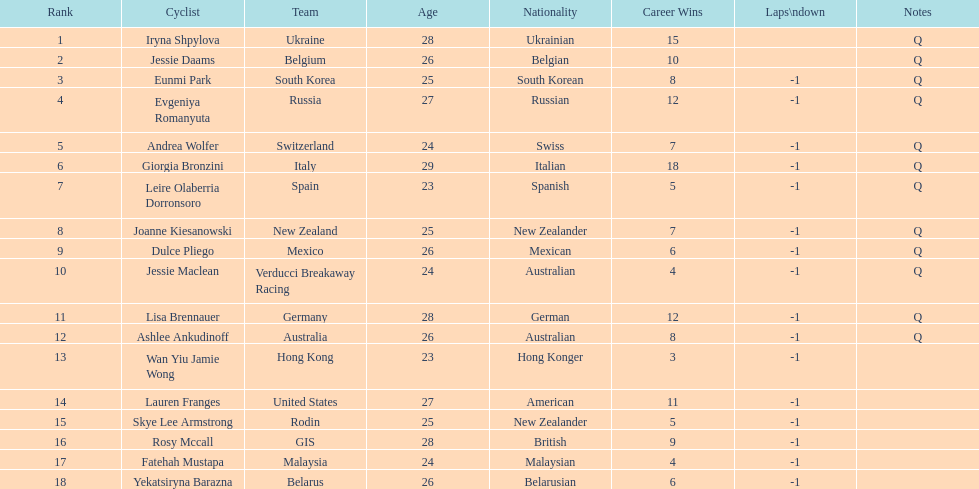How many cyclist do not have -1 laps down? 2. 